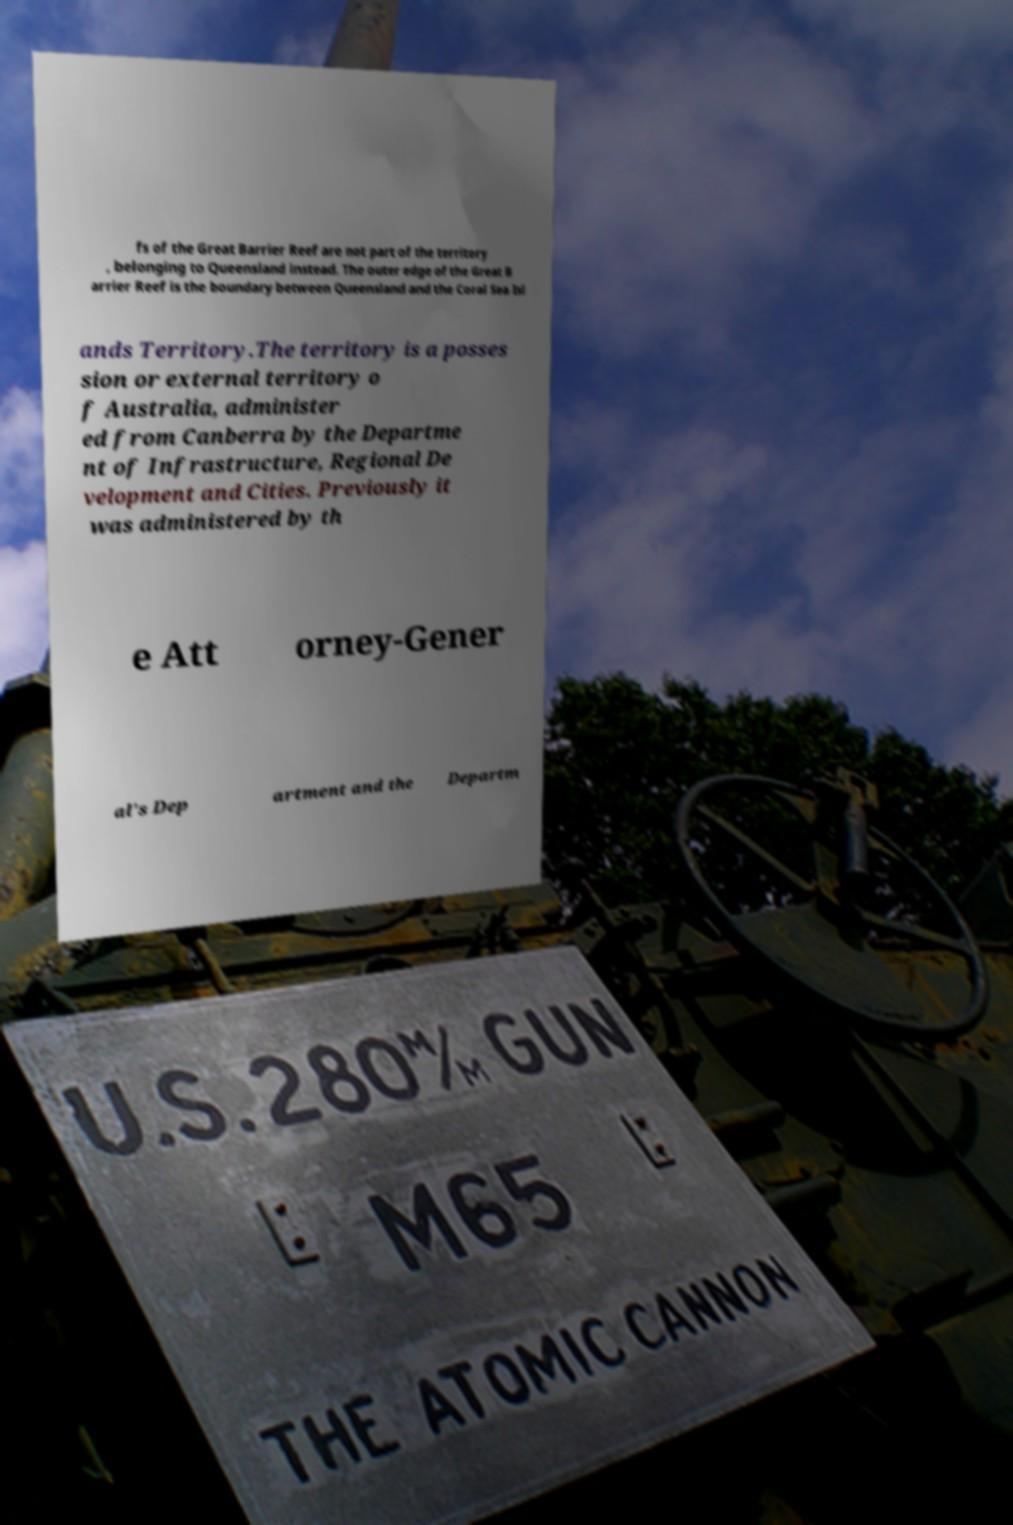What messages or text are displayed in this image? I need them in a readable, typed format. fs of the Great Barrier Reef are not part of the territory , belonging to Queensland instead. The outer edge of the Great B arrier Reef is the boundary between Queensland and the Coral Sea Isl ands Territory.The territory is a posses sion or external territory o f Australia, administer ed from Canberra by the Departme nt of Infrastructure, Regional De velopment and Cities. Previously it was administered by th e Att orney-Gener al's Dep artment and the Departm 